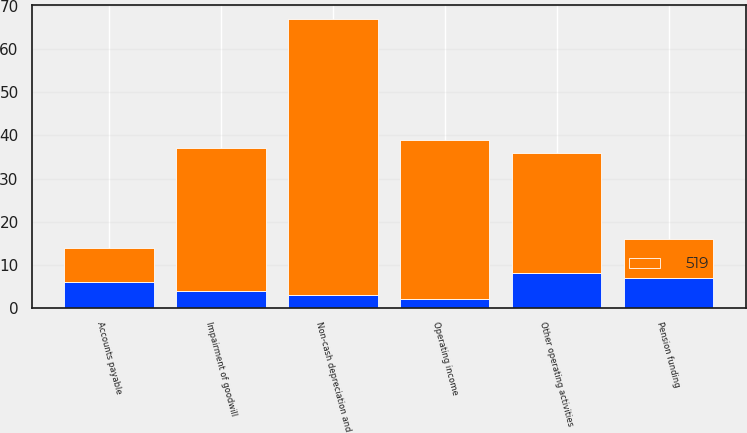<chart> <loc_0><loc_0><loc_500><loc_500><stacked_bar_chart><ecel><fcel>Operating income<fcel>Non-cash depreciation and<fcel>Impairment of goodwill<fcel>Accounts payable<fcel>Pension funding<fcel>Other operating activities<nl><fcel>519<fcel>37<fcel>64<fcel>33<fcel>8<fcel>9<fcel>28<nl><fcel>nan<fcel>2<fcel>3<fcel>4<fcel>6<fcel>7<fcel>8<nl></chart> 